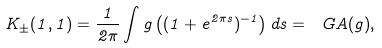Convert formula to latex. <formula><loc_0><loc_0><loc_500><loc_500>K _ { \pm } ( 1 , 1 ) = \frac { 1 } { 2 \pi } \int g \left ( ( 1 + e ^ { 2 \pi s } ) ^ { - 1 } \right ) d s = \ G A ( g ) ,</formula> 